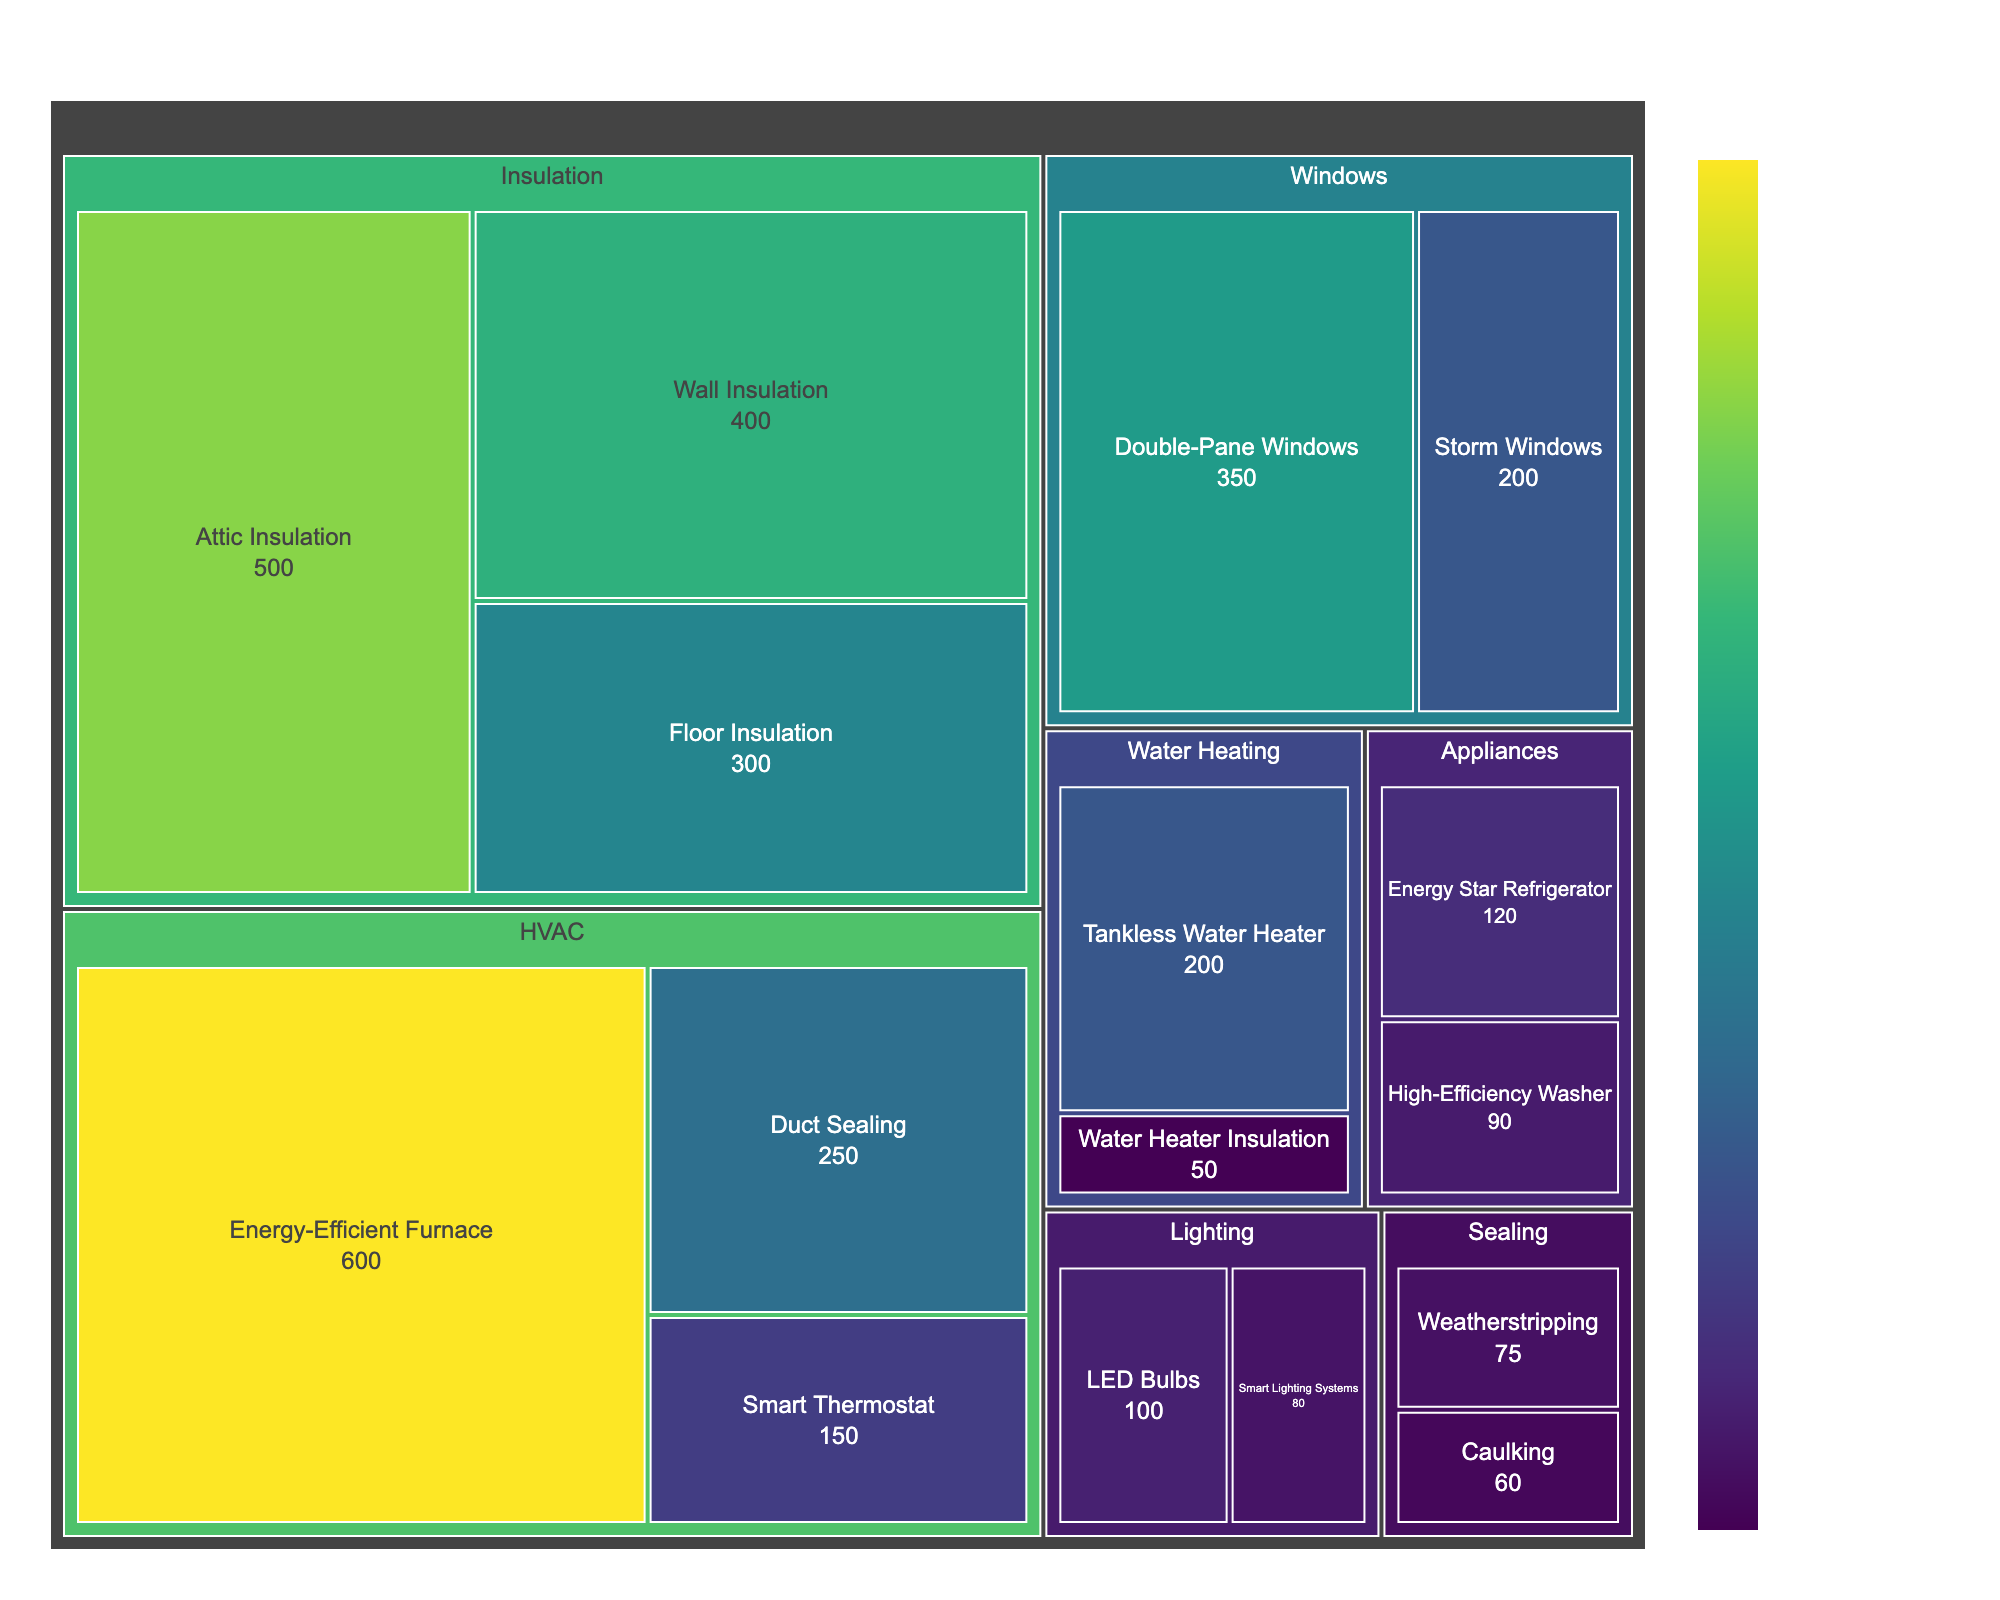What category has the highest potential savings from an upgrade? To find this, look for the category with the largest value among its upgrades. HVAC has the highest upgrade with the Energy-Efficient Furnace at $600.
Answer: HVAC Which upgrade in the Insulation category provides the highest potential savings? Identify the highest number in the Insulation category. Attic Insulation provides the highest savings at $500.
Answer: Attic Insulation What is the combined potential savings of Wall Insulation and Floor Insulation? Add the potential savings of Wall Insulation ($400) and Floor Insulation ($300). The total is $400 + $300.
Answer: $700 How do the savings from an Energy-Efficient Furnace compare to Double-Pane Windows? Compare the two values; Energy-Efficient Furnace is $600, and Double-Pane Windows is $350.
Answer: The Energy-Efficient Furnace has higher savings by $250 Which lighting upgrade offers lower potential savings, LED Bulbs or Smart Lighting Systems? Look for and compare the values of LED Bulbs ($100) and Smart Lighting Systems ($80).
Answer: Smart Lighting Systems How much higher are the potential savings of the Energy-Efficient Furnace as compared to Duct Sealing? Subtract the potential savings of Duct Sealing ($250) from Energy-Efficient Furnace ($600). The result is $600 - $250.
Answer: $350 What is the potential savings for the least beneficial upgrade within the Sealing category? Identify the smallest number in the Sealing category. Caulking has the lowest savings at $60.
Answer: $60 In the Water Heating category, which upgrade offers higher potential savings, and by how much? Compare the two values: Tankless Water Heater ($200) and Water Heater Insulation ($50). Subtract to find the difference: $200 - $50.
Answer: Tankless Water Heater by $150 What is the total potential savings for all upgrades in the Windows category? Add the potential savings of Double-Pane Windows ($350) and Storm Windows ($200). The total is $350 + $200.
Answer: $550 Which category offers the overall lowest potential savings, and what are its values? Find the category with the lowest individual values. Look at Sealing and Lighting. Compare Weatherstripping ($75) and Caulking ($60) to LED Bulbs ($100) and Smart Lighting Systems ($80). Sealing's values are $75 and $60.
Answer: Sealing, with $75 and $60 